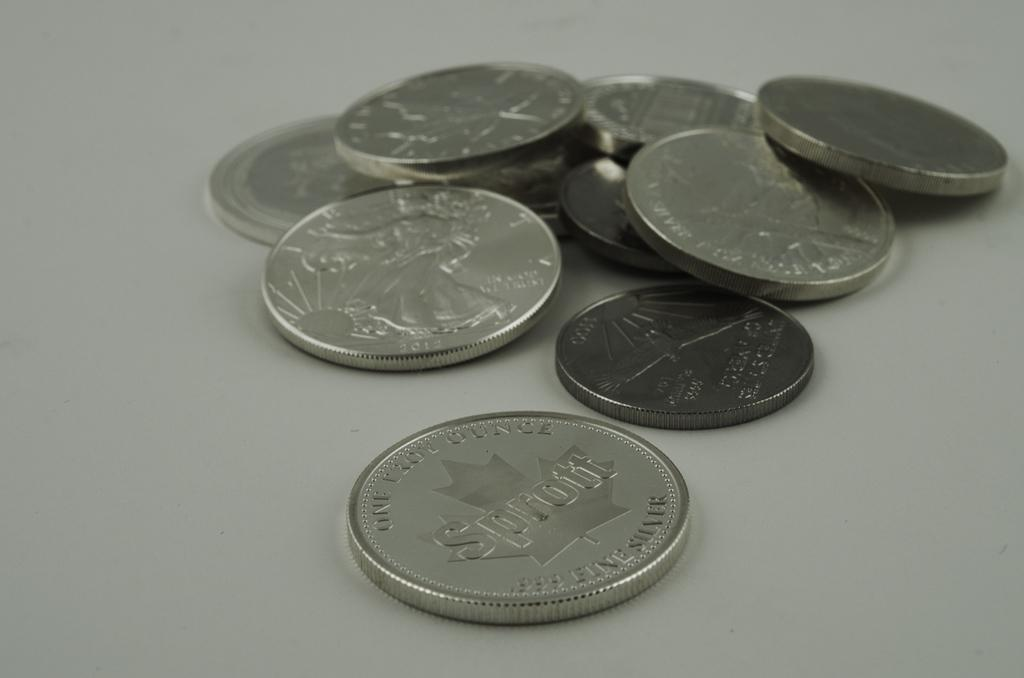<image>
Offer a succinct explanation of the picture presented. A pile of various coin currencies which one of the coins has the saying of Sprott on the front of it. 